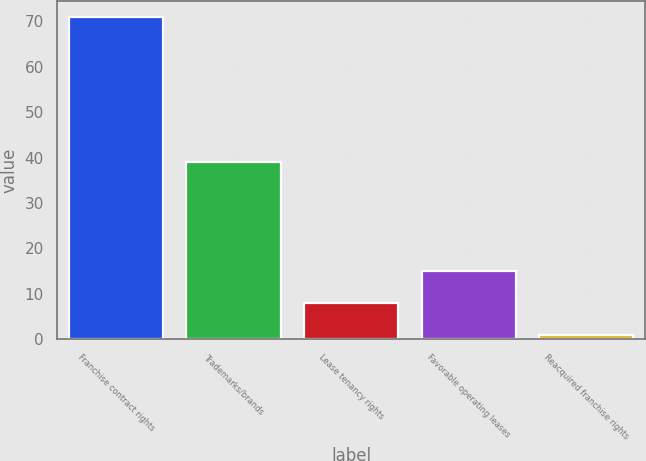<chart> <loc_0><loc_0><loc_500><loc_500><bar_chart><fcel>Franchise contract rights<fcel>Trademarks/brands<fcel>Lease tenancy rights<fcel>Favorable operating leases<fcel>Reacquired franchise rights<nl><fcel>71<fcel>39<fcel>8<fcel>15<fcel>1<nl></chart> 